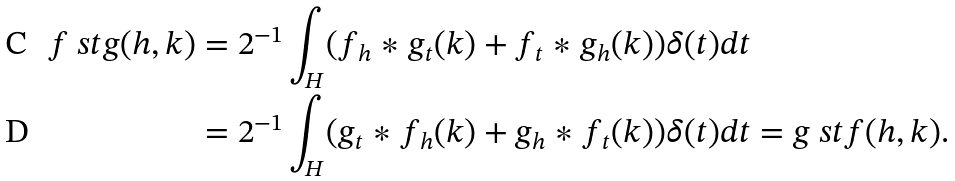Convert formula to latex. <formula><loc_0><loc_0><loc_500><loc_500>f \ s t g ( h , k ) & = 2 ^ { - 1 } \int _ { H } ( f _ { h } \ast g _ { t } ( k ) + f _ { t } \ast g _ { h } ( k ) ) \delta ( t ) d t \\ & = 2 ^ { - 1 } \int _ { H } ( g _ { t } \ast f _ { h } ( k ) + g _ { h } \ast f _ { t } ( k ) ) \delta ( t ) d t = g \ s t f ( h , k ) .</formula> 